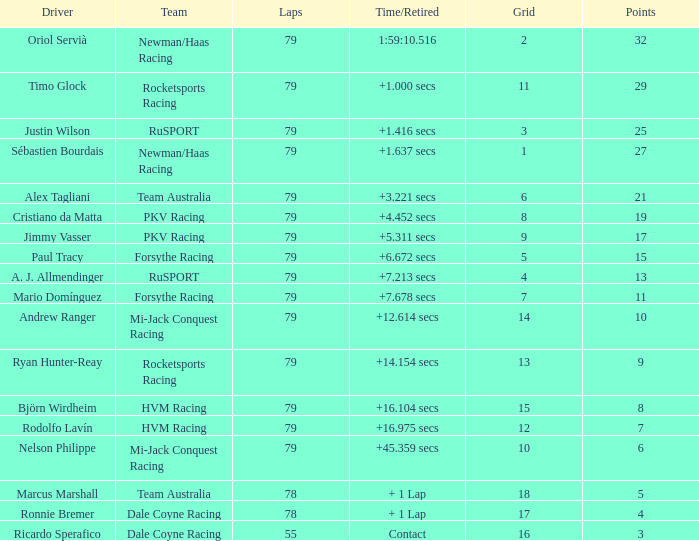On which grid with 78 laps is ronnie bremer the driver? 17.0. 